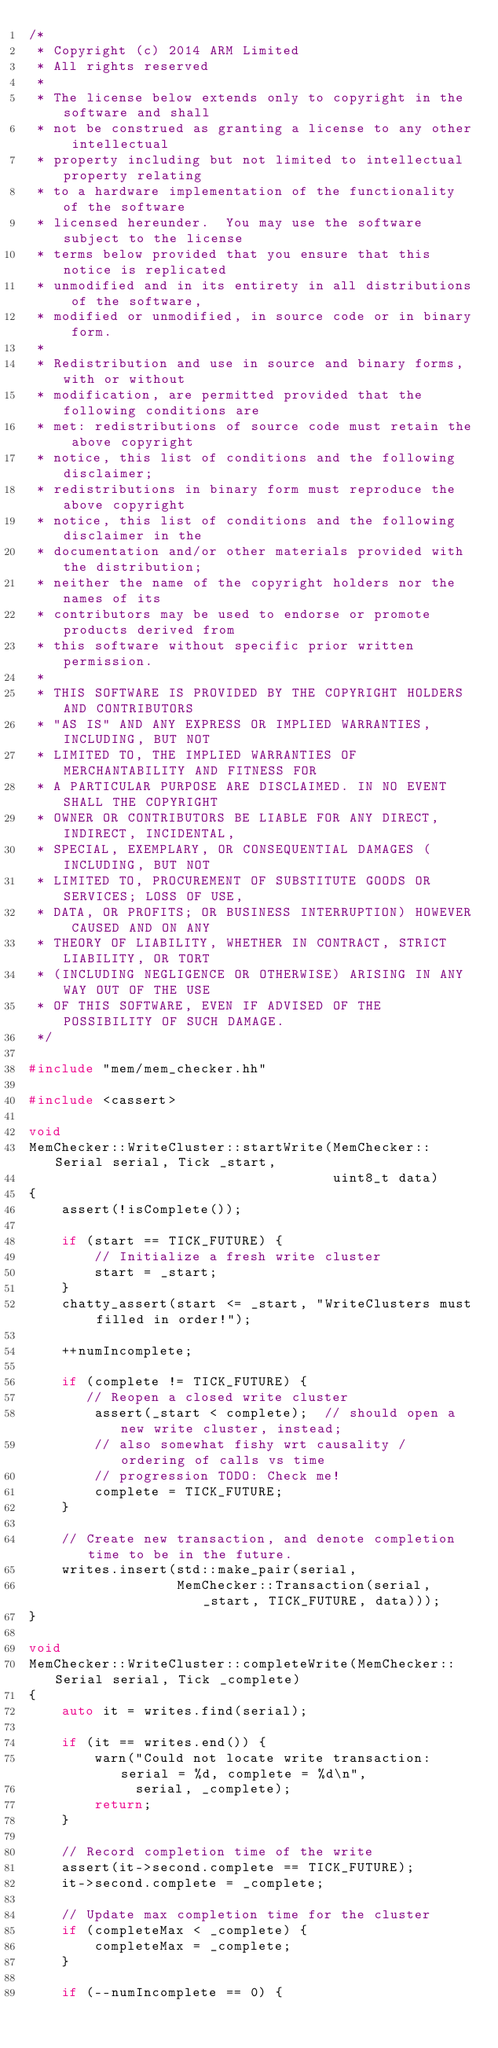Convert code to text. <code><loc_0><loc_0><loc_500><loc_500><_C++_>/*
 * Copyright (c) 2014 ARM Limited
 * All rights reserved
 *
 * The license below extends only to copyright in the software and shall
 * not be construed as granting a license to any other intellectual
 * property including but not limited to intellectual property relating
 * to a hardware implementation of the functionality of the software
 * licensed hereunder.  You may use the software subject to the license
 * terms below provided that you ensure that this notice is replicated
 * unmodified and in its entirety in all distributions of the software,
 * modified or unmodified, in source code or in binary form.
 *
 * Redistribution and use in source and binary forms, with or without
 * modification, are permitted provided that the following conditions are
 * met: redistributions of source code must retain the above copyright
 * notice, this list of conditions and the following disclaimer;
 * redistributions in binary form must reproduce the above copyright
 * notice, this list of conditions and the following disclaimer in the
 * documentation and/or other materials provided with the distribution;
 * neither the name of the copyright holders nor the names of its
 * contributors may be used to endorse or promote products derived from
 * this software without specific prior written permission.
 *
 * THIS SOFTWARE IS PROVIDED BY THE COPYRIGHT HOLDERS AND CONTRIBUTORS
 * "AS IS" AND ANY EXPRESS OR IMPLIED WARRANTIES, INCLUDING, BUT NOT
 * LIMITED TO, THE IMPLIED WARRANTIES OF MERCHANTABILITY AND FITNESS FOR
 * A PARTICULAR PURPOSE ARE DISCLAIMED. IN NO EVENT SHALL THE COPYRIGHT
 * OWNER OR CONTRIBUTORS BE LIABLE FOR ANY DIRECT, INDIRECT, INCIDENTAL,
 * SPECIAL, EXEMPLARY, OR CONSEQUENTIAL DAMAGES (INCLUDING, BUT NOT
 * LIMITED TO, PROCUREMENT OF SUBSTITUTE GOODS OR SERVICES; LOSS OF USE,
 * DATA, OR PROFITS; OR BUSINESS INTERRUPTION) HOWEVER CAUSED AND ON ANY
 * THEORY OF LIABILITY, WHETHER IN CONTRACT, STRICT LIABILITY, OR TORT
 * (INCLUDING NEGLIGENCE OR OTHERWISE) ARISING IN ANY WAY OUT OF THE USE
 * OF THIS SOFTWARE, EVEN IF ADVISED OF THE POSSIBILITY OF SUCH DAMAGE.
 */

#include "mem/mem_checker.hh"

#include <cassert>

void
MemChecker::WriteCluster::startWrite(MemChecker::Serial serial, Tick _start,
                                     uint8_t data)
{
    assert(!isComplete());

    if (start == TICK_FUTURE) {
        // Initialize a fresh write cluster
        start = _start;
    }
    chatty_assert(start <= _start, "WriteClusters must filled in order!");

    ++numIncomplete;

    if (complete != TICK_FUTURE) {
       // Reopen a closed write cluster
        assert(_start < complete);  // should open a new write cluster, instead;
        // also somewhat fishy wrt causality / ordering of calls vs time
        // progression TODO: Check me!
        complete = TICK_FUTURE;
    }

    // Create new transaction, and denote completion time to be in the future.
    writes.insert(std::make_pair(serial,
                  MemChecker::Transaction(serial, _start, TICK_FUTURE, data)));
}

void
MemChecker::WriteCluster::completeWrite(MemChecker::Serial serial, Tick _complete)
{
    auto it = writes.find(serial);

    if (it == writes.end()) {
        warn("Could not locate write transaction: serial = %d, complete = %d\n",
             serial, _complete);
        return;
    }

    // Record completion time of the write
    assert(it->second.complete == TICK_FUTURE);
    it->second.complete = _complete;

    // Update max completion time for the cluster
    if (completeMax < _complete) {
        completeMax = _complete;
    }

    if (--numIncomplete == 0) {</code> 